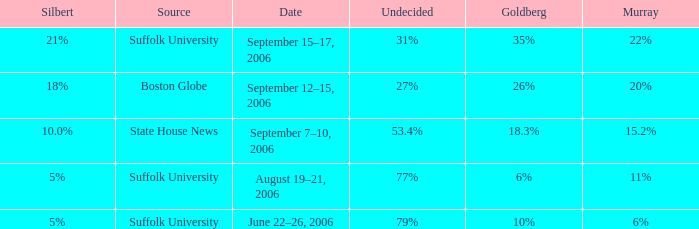What is the date of the poll with Silbert at 18%? September 12–15, 2006. 